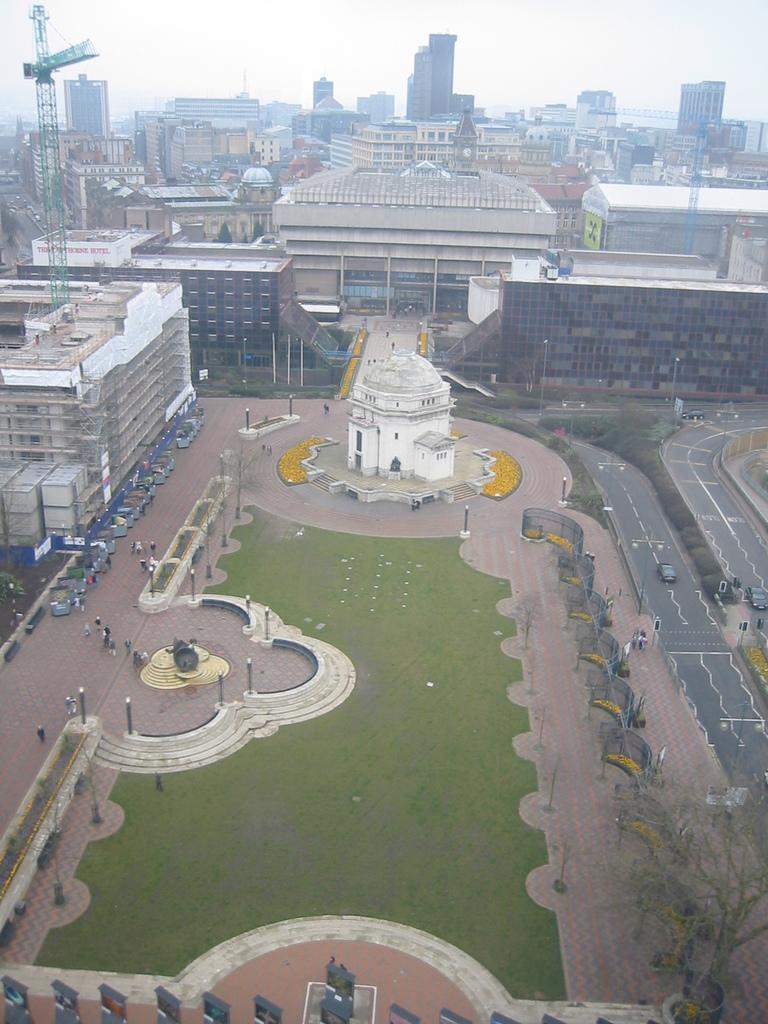Describe this image in one or two sentences. In this picture we can see some buildings are, on the left side there is a tower, we can see some people here, there is grass here, on the right side there are some trees, we can see two cars traveling on the road here, there are some poles and lights here, there is sky at the top of the picture. 